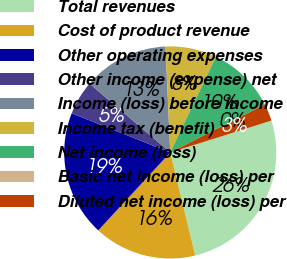Convert chart to OTSL. <chart><loc_0><loc_0><loc_500><loc_500><pie_chart><fcel>Total revenues<fcel>Cost of product revenue<fcel>Other operating expenses<fcel>Other income (expense) net<fcel>Income (loss) before income<fcel>Income tax (benefit)<fcel>Net income (loss)<fcel>Basic net income (loss) per<fcel>Diluted net income (loss) per<nl><fcel>26.08%<fcel>15.65%<fcel>19.15%<fcel>5.22%<fcel>13.04%<fcel>7.82%<fcel>10.43%<fcel>0.0%<fcel>2.61%<nl></chart> 